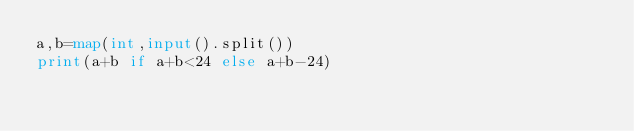<code> <loc_0><loc_0><loc_500><loc_500><_Python_>a,b=map(int,input().split())
print(a+b if a+b<24 else a+b-24)</code> 